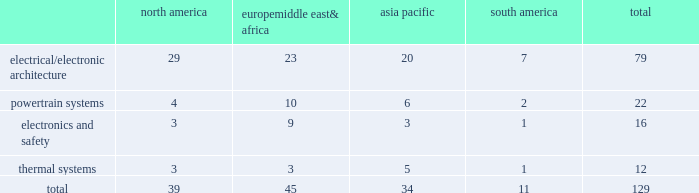Item 2 .
Properties as of december 31 , 2014 , we owned or leased 129 major manufacturing sites and 15 major technical centers in 33 countries .
A manufacturing site may include multiple plants and may be wholly or partially owned or leased .
We also have many smaller manufacturing sites , sales offices , warehouses , engineering centers , joint ventures and other investments strategically located throughout the world .
The table shows the regional distribution of our major manufacturing sites by the operating segment that uses such facilities : north america europe , middle east & africa asia pacific south america total .
In addition to these manufacturing sites , we had 15 major technical centers : five in north america ; five in europe , middle east and africa ; four in asia pacific ; and one in south america .
Of our 129 major manufacturing sites and 15 major technical centers , which include facilities owned or leased by our consolidated subsidiaries , 83 are primarily owned and 61 are primarily leased .
We frequently review our real estate portfolio and develop footprint strategies to support our customers 2019 global plans , while at the same time supporting our technical needs and controlling operating expenses .
We believe our evolving portfolio will meet current and anticipated future needs .
Item 3 .
Legal proceedings we are from time to time subject to various actions , claims , suits , government investigations , and other proceedings incidental to our business , including those arising out of alleged defects , breach of contracts , competition and antitrust matters , product warranties , intellectual property matters , personal injury claims and employment-related matters .
It is our opinion that the outcome of such matters will not have a material adverse impact on our consolidated financial position , results of operations , or cash flows .
With respect to warranty matters , although we cannot ensure that the future costs of warranty claims by customers will not be material , we believe our established reserves are adequate to cover potential warranty settlements .
However , the final amounts required to resolve these matters could differ materially from our recorded estimates .
Gm ignition switch recall in the first quarter of 2014 , gm , delphi 2019s largest customer , initiated a product recall related to ignition switches .
Delphi has received requests for information from , and is cooperating with , various government agencies related to this ignition switch recall .
In addition , delphi has been named as a co-defendant along with gm ( and in certain cases other parties ) in product liability and class action lawsuits related to this matter .
During the second quarter of 2014 , all of the class action cases were transferred to the united states district court for the southern district of new york ( the 201cdistrict court 201d ) for coordinated pretrial proceedings .
Two consolidated amended class action complaints were filed in the district court on october 14 , 2014 .
Delphi was not named as a defendant in either complaint .
Delphi believes the allegations contained in the product liability cases are without merit , and intends to vigorously defend against them .
Although no assurances can be made as to the ultimate outcome of these or any other future claims , delphi does not believe a loss is probable and , accordingly , no reserve has been made as of december 31 , 2014 .
Unsecured creditors litigation under the terms of the fourth amended and restated limited liability partnership agreement of delphi automotive llp ( the 201cfourth llp agreement 201d ) , if cumulative distributions to the members of delphi automotive llp under certain provisions of the fourth llp agreement exceed $ 7.2 billion , delphi , as disbursing agent on behalf of dphh , is required to pay to the holders of allowed general unsecured claims against old delphi , $ 32.50 for every $ 67.50 in excess of $ 7.2 billion distributed to the members , up to a maximum amount of $ 300 million .
In december 2014 , a complaint was filed in the bankruptcy court alleging that the redemption by delphi automotive llp of the membership interests of gm and the pbgc , and the repurchase of shares and payment of dividends by delphi automotive plc , constituted distributions under the terms of the fourth llp agreement approximating $ 7.2 billion .
Delphi considers cumulative distributions through december 31 , 2014 to be substantially below the $ 7.2 billion threshold , and intends to vigorously contest the allegations set forth in the complaint .
Accordingly , no accrual for this matter has been recorded as of december 31 , 2014. .
What percentage of major manufacturing sites are in europe middle east& africa? 
Computations: (45 / 129)
Answer: 0.34884. 